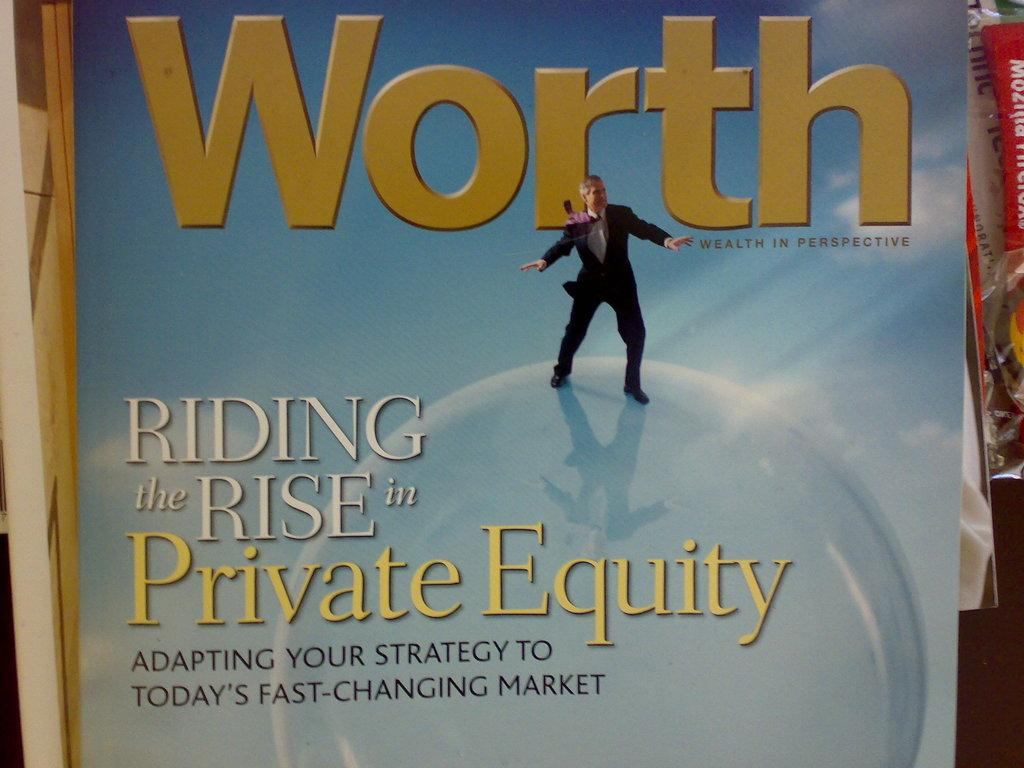Provide a one-sentence caption for the provided image. An issue of Worth magazine discusses private equity. 